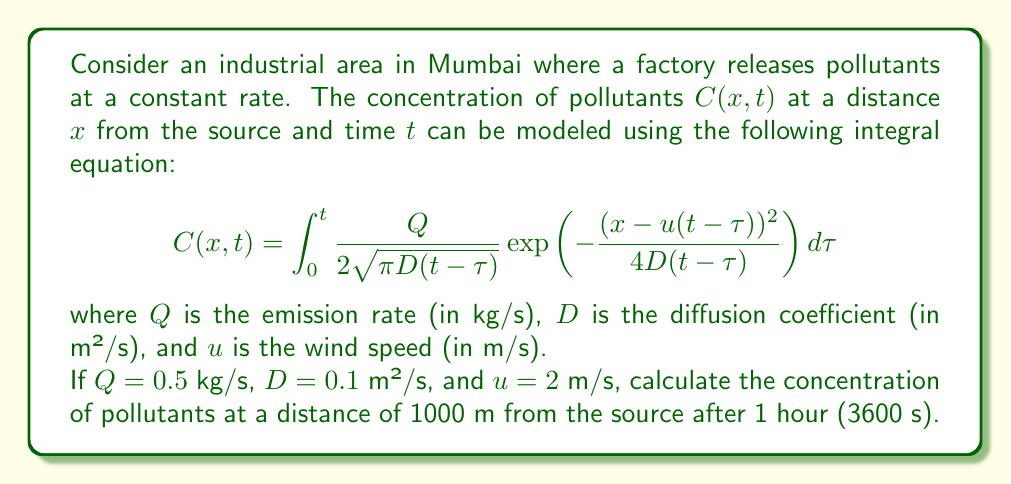Could you help me with this problem? To solve this problem, we need to evaluate the integral equation with the given parameters. Let's break it down step-by-step:

1) First, let's substitute the given values into the equation:
   $x = 1000$ m
   $t = 3600$ s
   $Q = 0.5$ kg/s
   $D = 0.1$ m²/s
   $u = 2$ m/s

2) The integral equation becomes:

   $$C(1000,3600) = \int_0^{3600} \frac{0.5}{2\sqrt{\pi \cdot 0.1(3600-\tau)}} \exp\left(-\frac{(1000-2(3600-\tau))^2}{4\cdot 0.1(3600-\tau)}\right) d\tau$$

3) This integral is complex and doesn't have a simple analytical solution. In practice, it would be evaluated numerically using computational methods.

4) However, we can simplify it slightly:

   $$C(1000,3600) = \frac{0.5}{2\sqrt{0.1\pi}} \int_0^{3600} \frac{1}{\sqrt{3600-\tau}} \exp\left(-\frac{(1000-7200+2\tau)^2}{0.4(3600-\tau)}\right) d\tau$$

5) To evaluate this integral, we would typically use numerical integration techniques such as the trapezoidal rule or Simpson's rule, or use computational software.

6) After numerical evaluation (which would be done by a computer), we would get a result in kg/m³.

7) This result represents the concentration of pollutants 1000 m downwind from the factory after 1 hour of continuous emission.
Answer: The concentration can be determined by numerical evaluation of the integral:

$$C(1000,3600) = \frac{0.5}{2\sqrt{0.1\pi}} \int_0^{3600} \frac{1}{\sqrt{3600-\tau}} \exp\left(-\frac{(1000-7200+2\tau)^2}{0.4(3600-\tau)}\right) d\tau$$ kg/m³ 